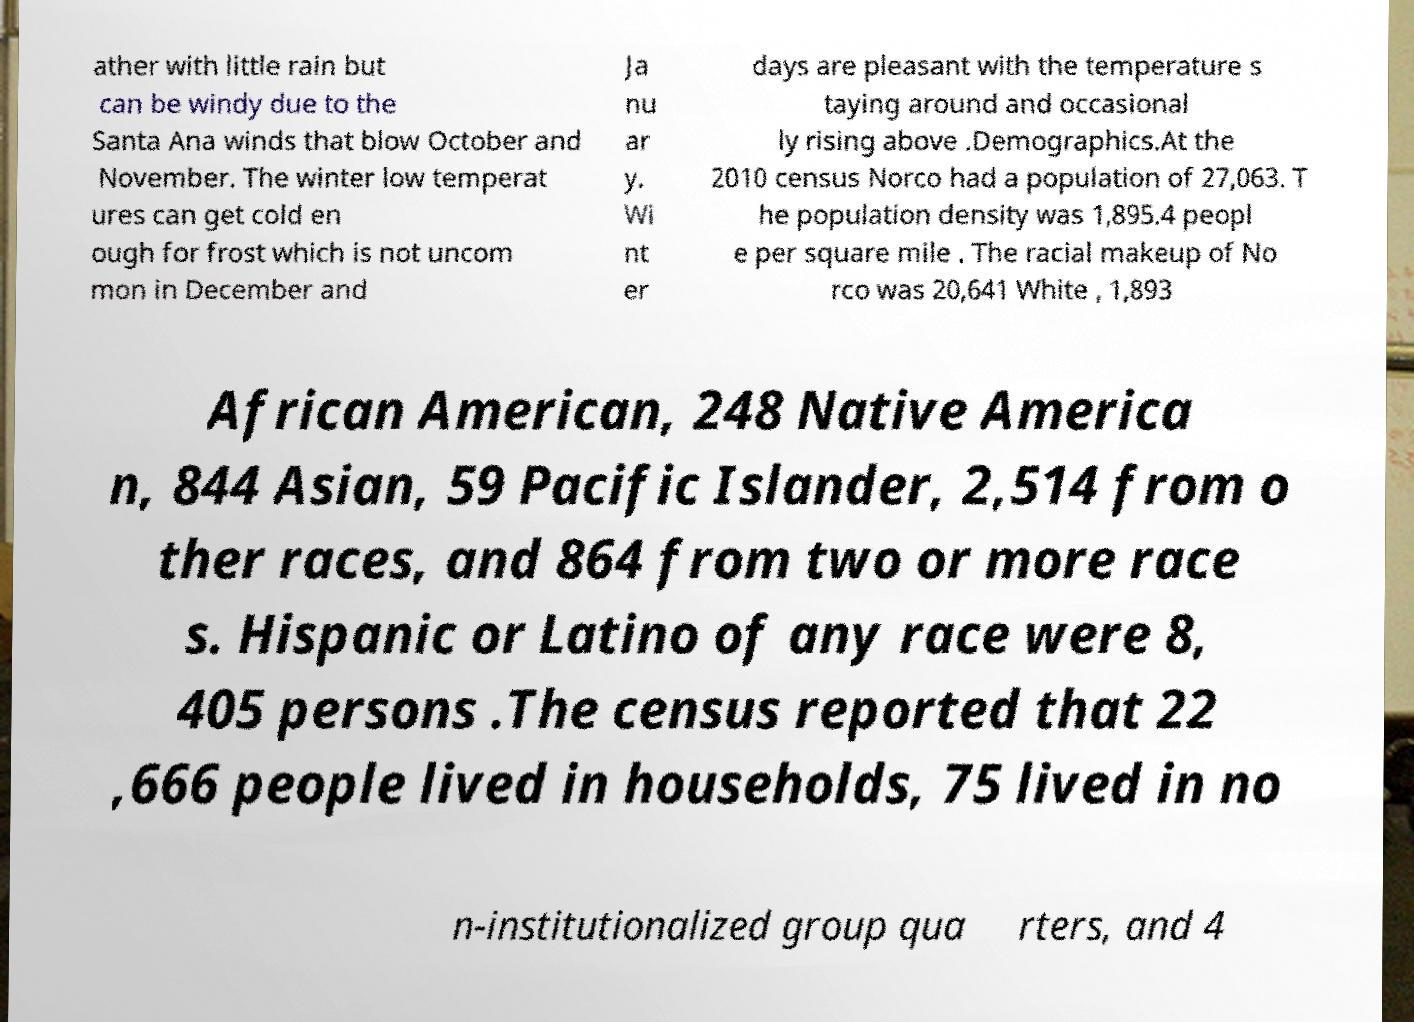I need the written content from this picture converted into text. Can you do that? ather with little rain but can be windy due to the Santa Ana winds that blow October and November. The winter low temperat ures can get cold en ough for frost which is not uncom mon in December and Ja nu ar y. Wi nt er days are pleasant with the temperature s taying around and occasional ly rising above .Demographics.At the 2010 census Norco had a population of 27,063. T he population density was 1,895.4 peopl e per square mile . The racial makeup of No rco was 20,641 White , 1,893 African American, 248 Native America n, 844 Asian, 59 Pacific Islander, 2,514 from o ther races, and 864 from two or more race s. Hispanic or Latino of any race were 8, 405 persons .The census reported that 22 ,666 people lived in households, 75 lived in no n-institutionalized group qua rters, and 4 